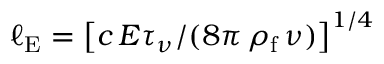Convert formula to latex. <formula><loc_0><loc_0><loc_500><loc_500>\ell _ { E } = \left [ c \, E \tau _ { \nu } / ( 8 \pi \, \rho _ { f } \, \nu ) \right ] ^ { 1 / 4 }</formula> 